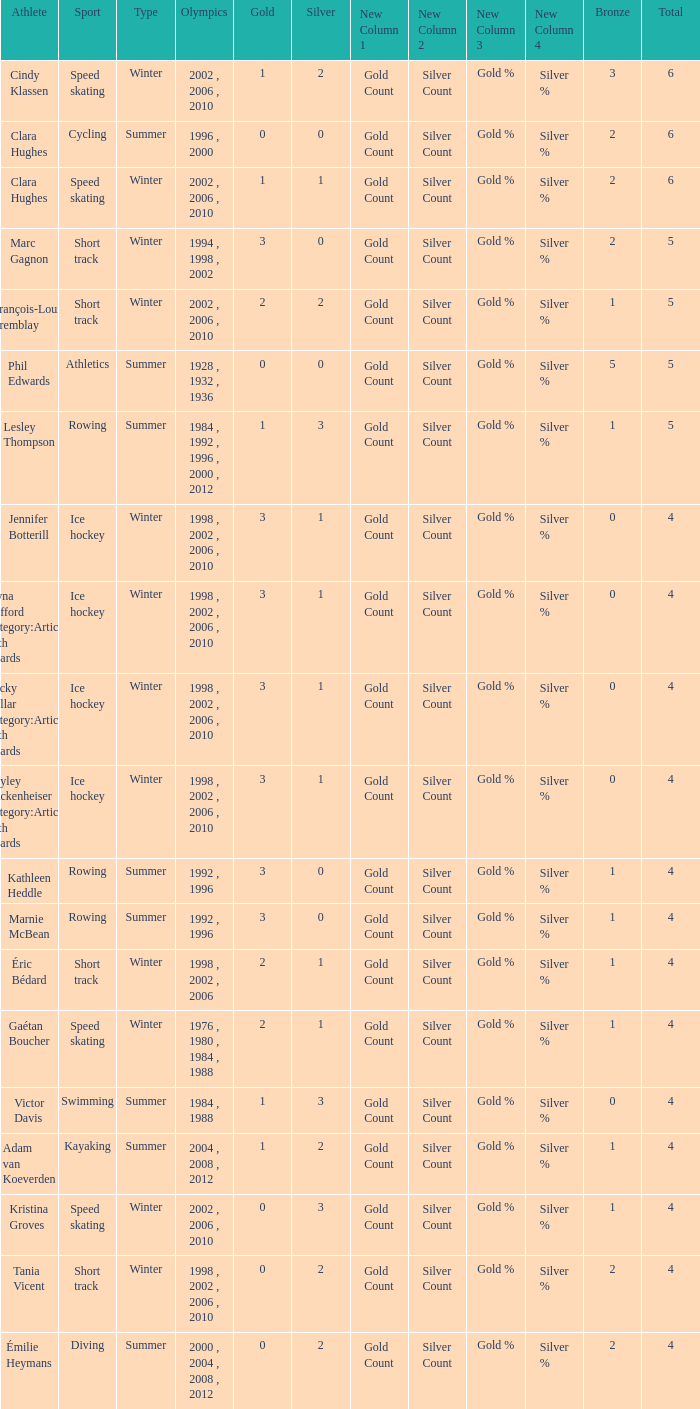What is the average gold of the winter athlete with 1 bronze, less than 3 silver, and less than 4 total medals? None. 